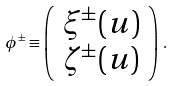<formula> <loc_0><loc_0><loc_500><loc_500>\phi ^ { \pm } \equiv \left ( \begin{array} { c } \xi ^ { \pm } ( u ) \\ \zeta ^ { \pm } ( u ) \end{array} \right ) \, .</formula> 